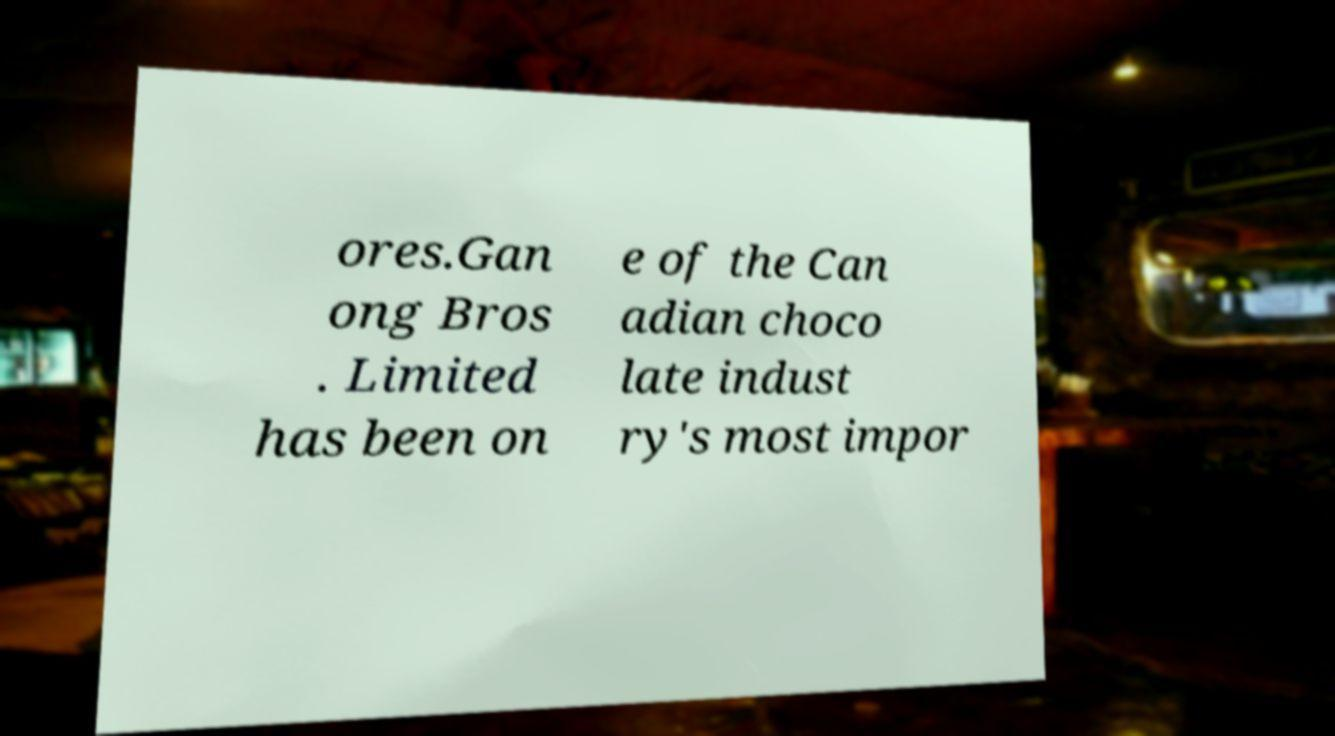Can you read and provide the text displayed in the image?This photo seems to have some interesting text. Can you extract and type it out for me? ores.Gan ong Bros . Limited has been on e of the Can adian choco late indust ry's most impor 